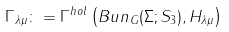<formula> <loc_0><loc_0><loc_500><loc_500>\Gamma _ { \lambda \mu } \colon = \Gamma ^ { h o l } \left ( B u n _ { G } ( \Sigma ; S _ { 3 } ) , H _ { \lambda \mu } \right )</formula> 